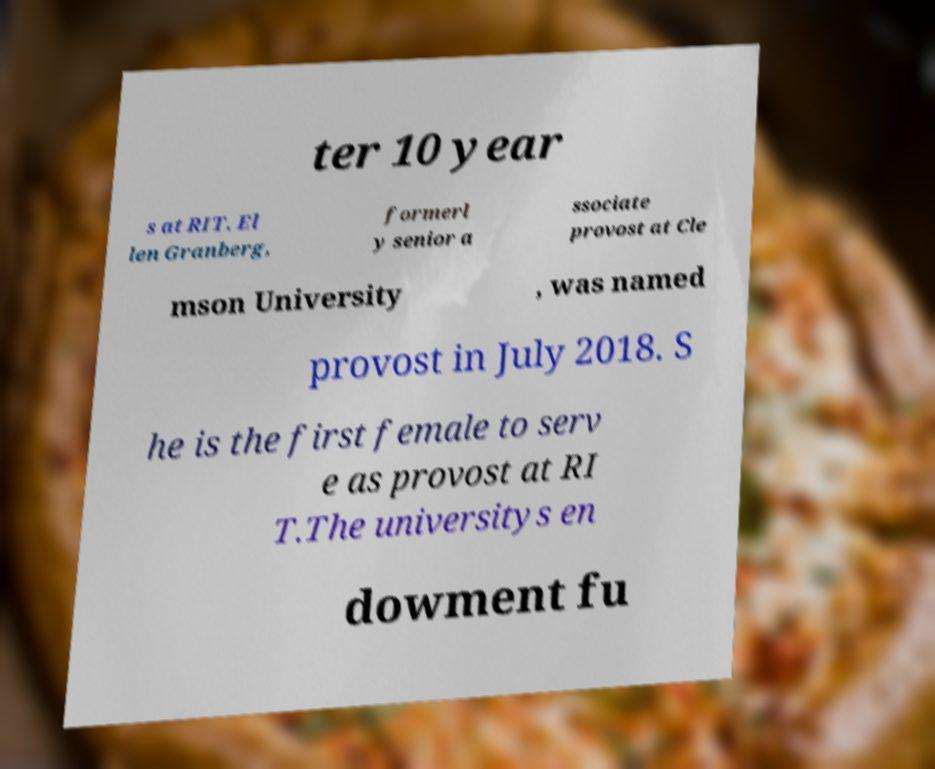Could you extract and type out the text from this image? ter 10 year s at RIT. El len Granberg, formerl y senior a ssociate provost at Cle mson University , was named provost in July 2018. S he is the first female to serv e as provost at RI T.The universitys en dowment fu 